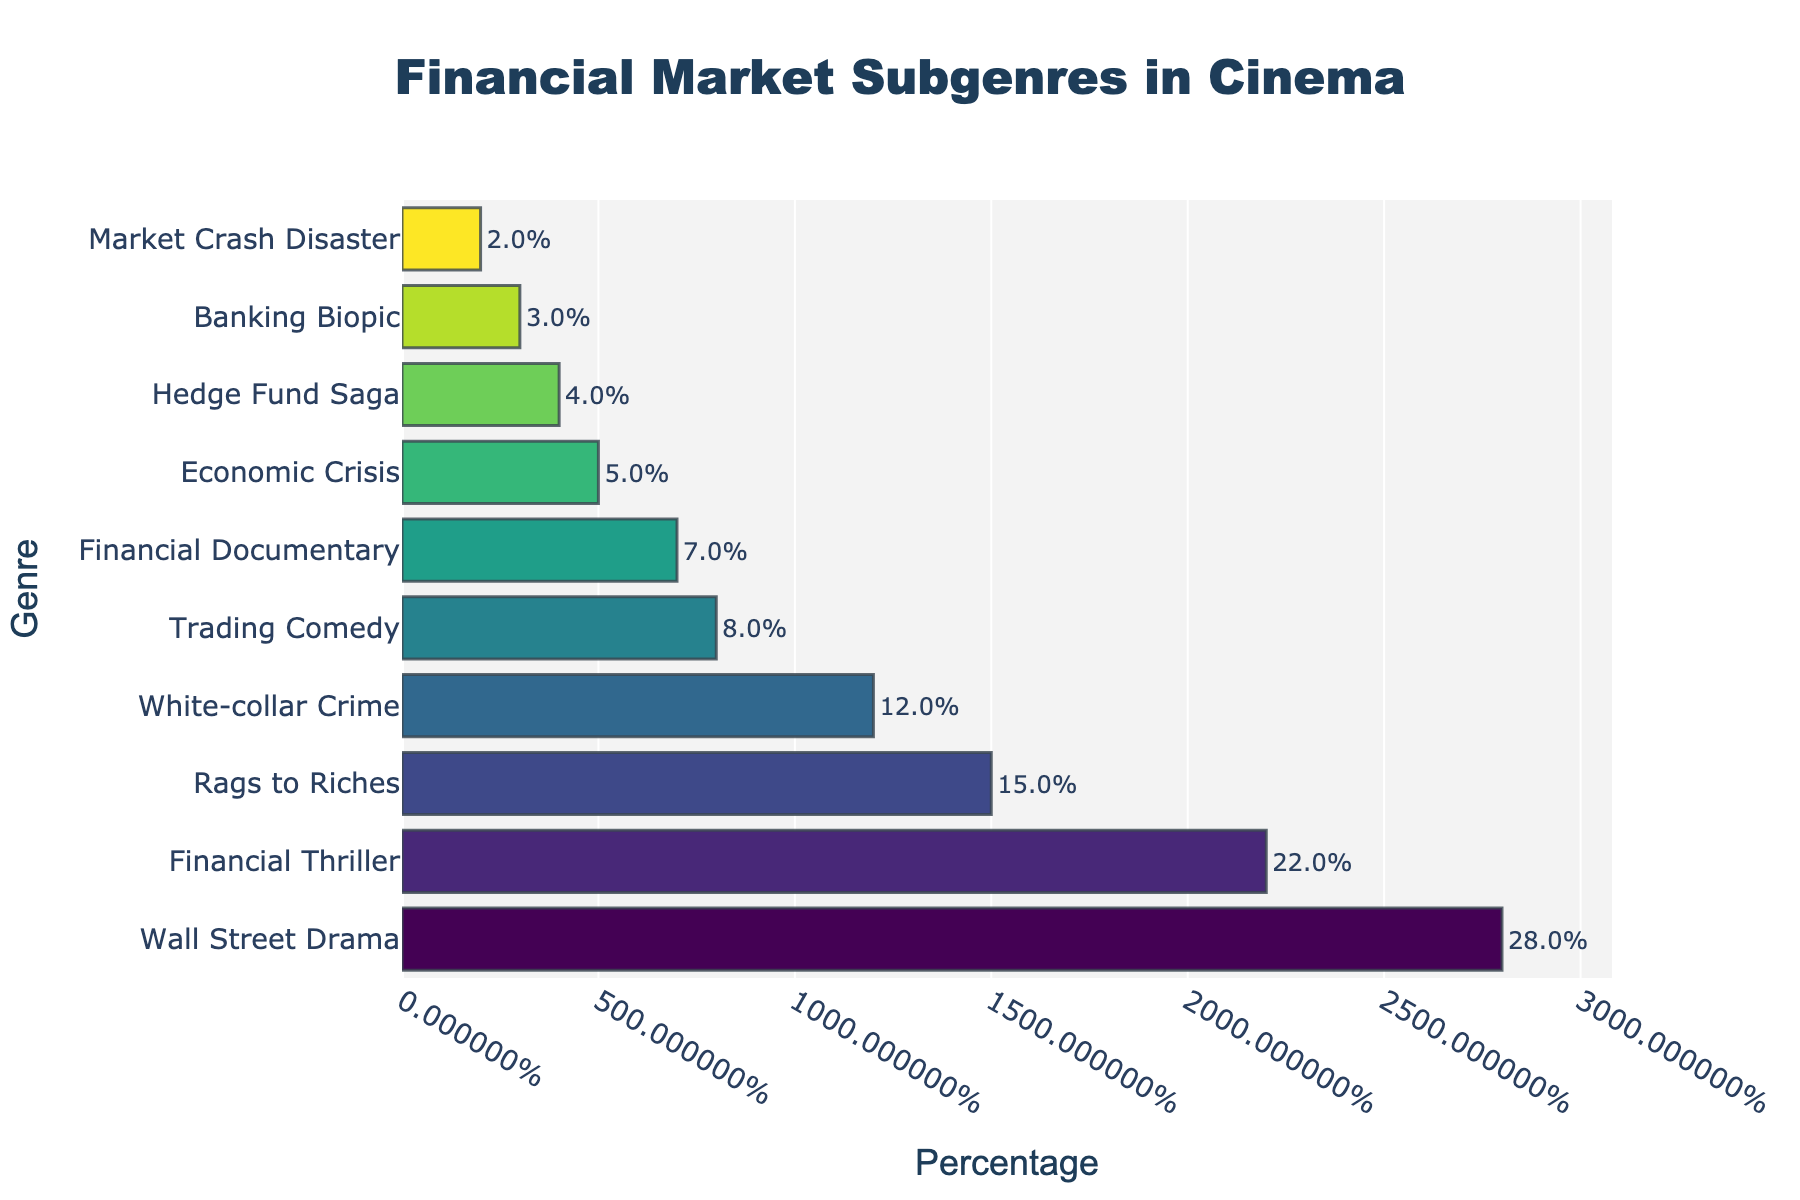Which subgenre has the highest percentage? The subgenre with the highest percentage is at the top of the bar chart, and looking at the chart, the "Wall Street Drama" subgenre has the longest bar.
Answer: Wall Street Drama Which subgenre occupies the lowest percentage? The subgenre with the lowest percentage is at the bottom of the bar chart, and based on the lengths of the bars, "Market Crash Disaster" has the shortest bar.
Answer: Market Crash Disaster What is the combined percentage of "White-collar Crime" and "Economic Crisis"? Locate the bars for "White-collar Crime" and "Economic Crisis," add their percentages: 12 + 5. This results in a combined percentage.
Answer: 17 How much greater is the percentage of "Financial Thriller" compared to "Trading Comedy"? Find the bars representing "Financial Thriller" and "Trading Comedy," then subtract the percentage of "Trading Comedy" from the "Financial Thriller": 22 - 8.
Answer: 14 What is the average percentage of the top three subgenres? Identify the top three subgenres by their percentages: "Wall Street Drama" (28), "Financial Thriller" (22), and "Rags to Riches" (15). Calculate their average: (28 + 22 + 15) / 3.
Answer: 21.67 Which subgenre appears to be colored by the second most intense color? Colors on the chart correspond to their percentages. Since the intensity of the color increases with higher percentages, the second most intense color will be the second highest bar. "Financial Thriller" is just below "Wall Street Drama."
Answer: Financial Thriller What is the difference in percentage between the total of the top five subgenres and the bottom five subgenres? First compute the total of the top five subgenres: "Wall Street Drama" (28) + "Financial Thriller" (22) + "Rags to Riches" (15) + "White-collar Crime" (12) + "Trading Comedy" (8) = 85. Then compute the total of the bottom five subgenres: "Banking Biopic" (3) + "Hedge Fund Saga" (4) + "Economic Crisis" (5) + "Financial Documentary" (7) + "Market Crash Disaster" (2) = 21. Finally, find the difference: 85 - 21.
Answer: 64 Which three subgenres together make up almost half of the total percentage? To find three subgenres that together make up almost half of the total percentage (50%), look for combinations that sum up to close to 50. "Wall Street Drama" (28), "Financial Thriller" (22) together make 50, which is exactly half.
Answer: Wall Street Drama, Financial Thriller If a new subgenre were to be added with a percentage equal to the sum of "Banking Biopic" and "Market Crash Disaster," what would its percentage be and where would it fall on the chart? First, add the percentages of "Banking Biopic" and "Market Crash Disaster": 3 + 2 = 5. A new subgenre with a percentage of 5 would fall between "Financial Documentary" (7) and "Market Crash Disaster" (2) on the chart.
Answer: 5, between Financial Documentary and Market Crash Disaster 